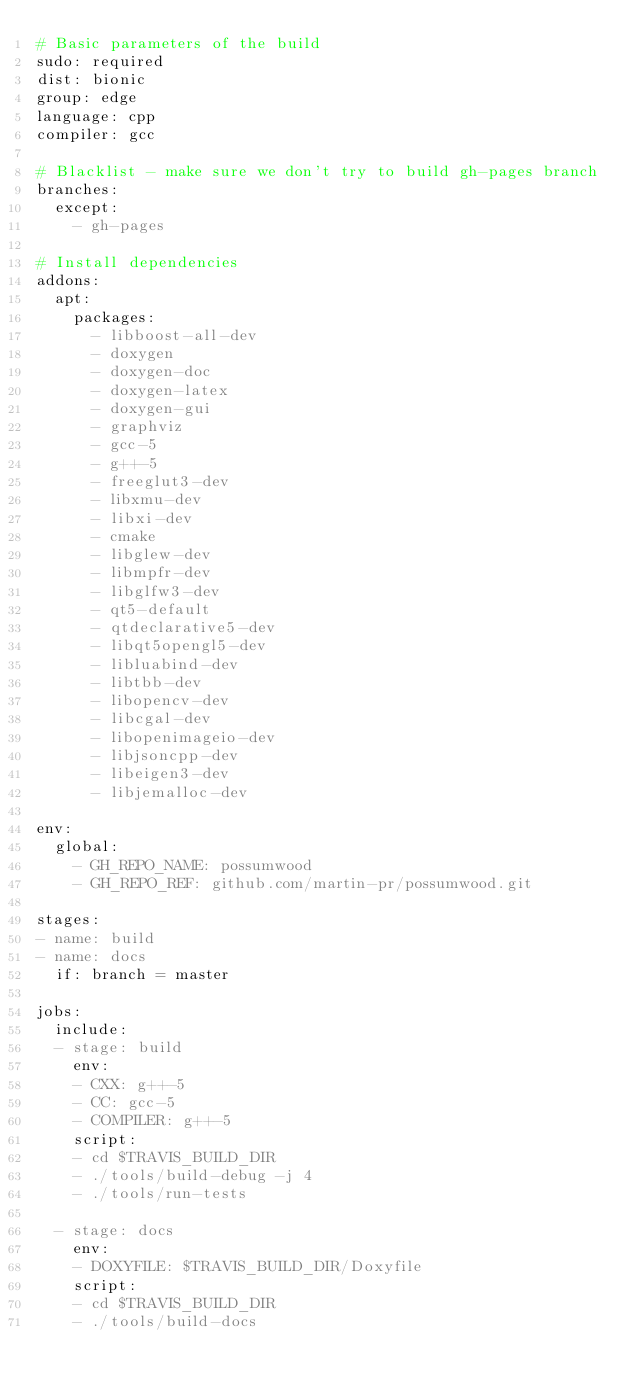<code> <loc_0><loc_0><loc_500><loc_500><_YAML_># Basic parameters of the build
sudo: required
dist: bionic
group: edge
language: cpp
compiler: gcc

# Blacklist - make sure we don't try to build gh-pages branch
branches:
  except:
    - gh-pages

# Install dependencies
addons:
  apt:
    packages:
      - libboost-all-dev
      - doxygen
      - doxygen-doc
      - doxygen-latex
      - doxygen-gui
      - graphviz
      - gcc-5
      - g++-5
      - freeglut3-dev
      - libxmu-dev
      - libxi-dev
      - cmake
      - libglew-dev
      - libmpfr-dev
      - libglfw3-dev
      - qt5-default
      - qtdeclarative5-dev
      - libqt5opengl5-dev
      - libluabind-dev
      - libtbb-dev
      - libopencv-dev
      - libcgal-dev
      - libopenimageio-dev
      - libjsoncpp-dev
      - libeigen3-dev
      - libjemalloc-dev

env:
  global:
    - GH_REPO_NAME: possumwood
    - GH_REPO_REF: github.com/martin-pr/possumwood.git

stages:
- name: build
- name: docs
  if: branch = master

jobs:
  include:
  - stage: build
    env:
    - CXX: g++-5
    - CC: gcc-5
    - COMPILER: g++-5
    script:
    - cd $TRAVIS_BUILD_DIR
    - ./tools/build-debug -j 4
    - ./tools/run-tests

  - stage: docs
    env:
    - DOXYFILE: $TRAVIS_BUILD_DIR/Doxyfile
    script:
    - cd $TRAVIS_BUILD_DIR
    - ./tools/build-docs
</code> 